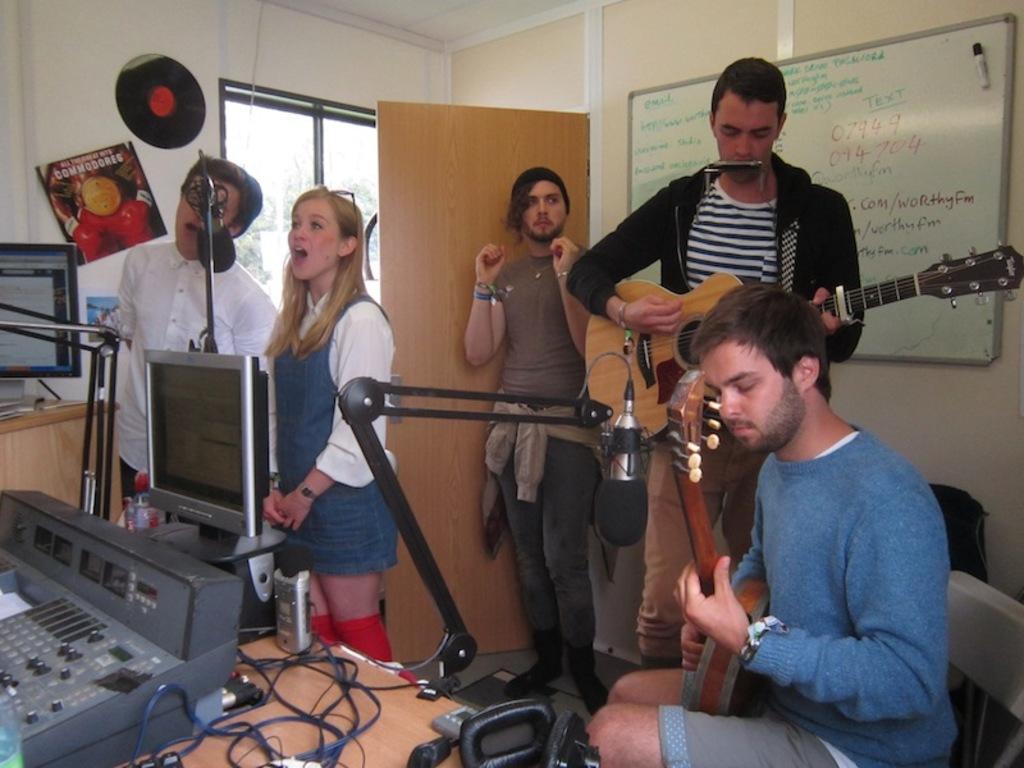Could you give a brief overview of what you see in this image? The image is inside the room. In the image there are group of people on right side there is a man sitting on chair and playing a musical instrument and we can also see a black color shirt man standing and playing a guitar. In middle there is a man standing on left side also two people men and women are standing in front of a table. On table we can see a monitor,wired,headset. In background there is a white color wall and a wall which is closed. 